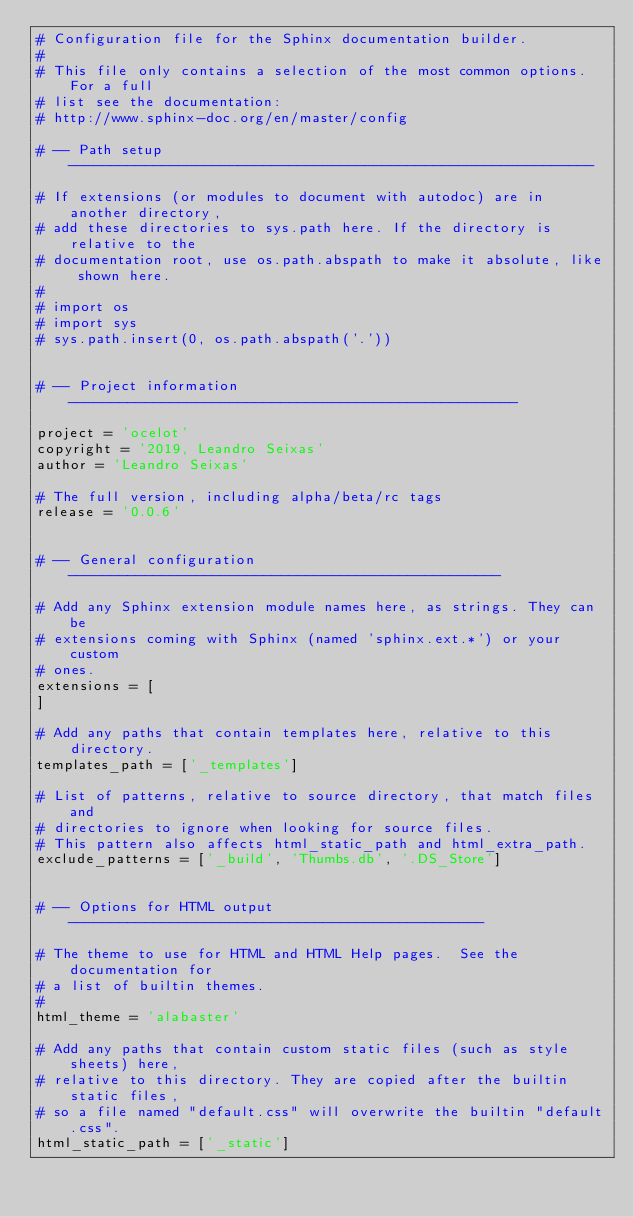<code> <loc_0><loc_0><loc_500><loc_500><_Python_># Configuration file for the Sphinx documentation builder.
#
# This file only contains a selection of the most common options. For a full
# list see the documentation:
# http://www.sphinx-doc.org/en/master/config

# -- Path setup --------------------------------------------------------------

# If extensions (or modules to document with autodoc) are in another directory,
# add these directories to sys.path here. If the directory is relative to the
# documentation root, use os.path.abspath to make it absolute, like shown here.
#
# import os
# import sys
# sys.path.insert(0, os.path.abspath('.'))


# -- Project information -----------------------------------------------------

project = 'ocelot'
copyright = '2019, Leandro Seixas'
author = 'Leandro Seixas'

# The full version, including alpha/beta/rc tags
release = '0.0.6'


# -- General configuration ---------------------------------------------------

# Add any Sphinx extension module names here, as strings. They can be
# extensions coming with Sphinx (named 'sphinx.ext.*') or your custom
# ones.
extensions = [
]

# Add any paths that contain templates here, relative to this directory.
templates_path = ['_templates']

# List of patterns, relative to source directory, that match files and
# directories to ignore when looking for source files.
# This pattern also affects html_static_path and html_extra_path.
exclude_patterns = ['_build', 'Thumbs.db', '.DS_Store']


# -- Options for HTML output -------------------------------------------------

# The theme to use for HTML and HTML Help pages.  See the documentation for
# a list of builtin themes.
#
html_theme = 'alabaster'

# Add any paths that contain custom static files (such as style sheets) here,
# relative to this directory. They are copied after the builtin static files,
# so a file named "default.css" will overwrite the builtin "default.css".
html_static_path = ['_static']
</code> 